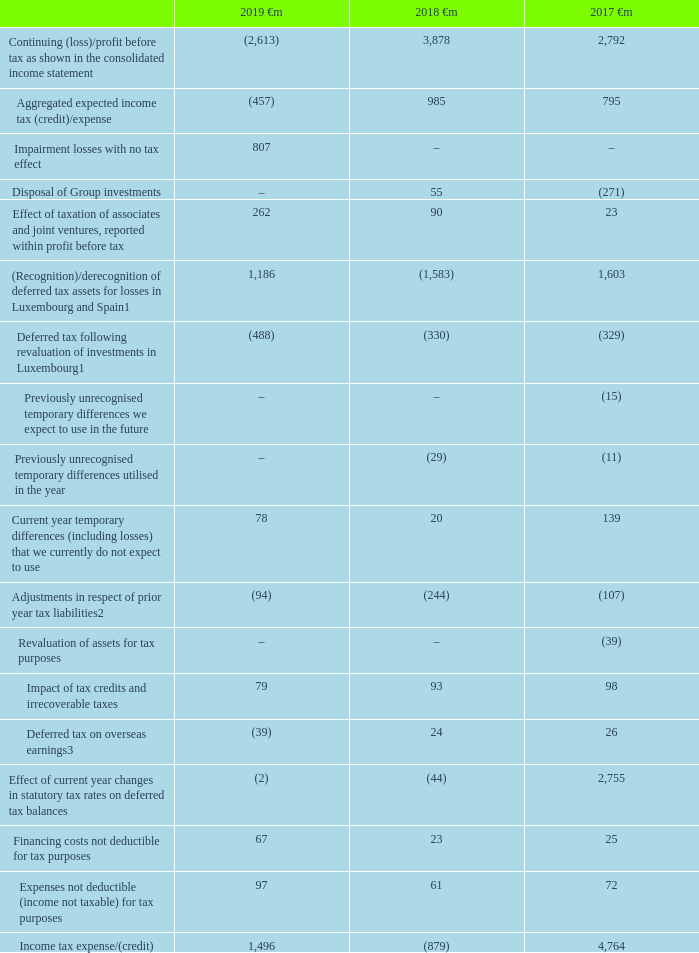Factors affecting the tax expense for the year
The table below explains the differences between the expected tax expense, being the aggregate of the Group’s geographical split of profits multiplied by the relevant local tax rates and the Group’s total tax expense for each year.
Notes: 1 See note below regarding deferred tax asset recognition in Luxembourg and Spain on pages 140 and 141
2 2018 includes the impact of closing tax audits across the Group during the year, including in Germany and Romania
3 Includes a €42 million credit (2018: €15 million charge, 2017 €95 million charge) relating to the combination of Vodafone India with Idea Cellular
Which financial years' information is shown in the table? 2017, 2018, 2019. What does the table explain? The differences between the expected tax expense, being the aggregate of the group’s geographical split of profits multiplied by the relevant local tax rates and the group’s total tax expense for each year. How much is the 2018 aggregated expected income expense ?
Answer scale should be: million. 985. What is the 2018 deferred tax on overseas earnings, excluding the 15€m charge relating to the combination of Vodafone India with Idea Cellular?
Answer scale should be: million. 24-15
Answer: 9. What is the 2017 deferred tax on overseas earnings, excluding the 95€m charge relating to the combination of Vodafone India with Idea Cellular?
Answer scale should be: million. 26-95
Answer: -69. What is the change between 2017-2018 and 2018-2019 average income tax expense?
Answer scale should be: million. [1,496 +(-879)]/ 2 - [(-879)+ 4,764]/ 2
Answer: -1634. 